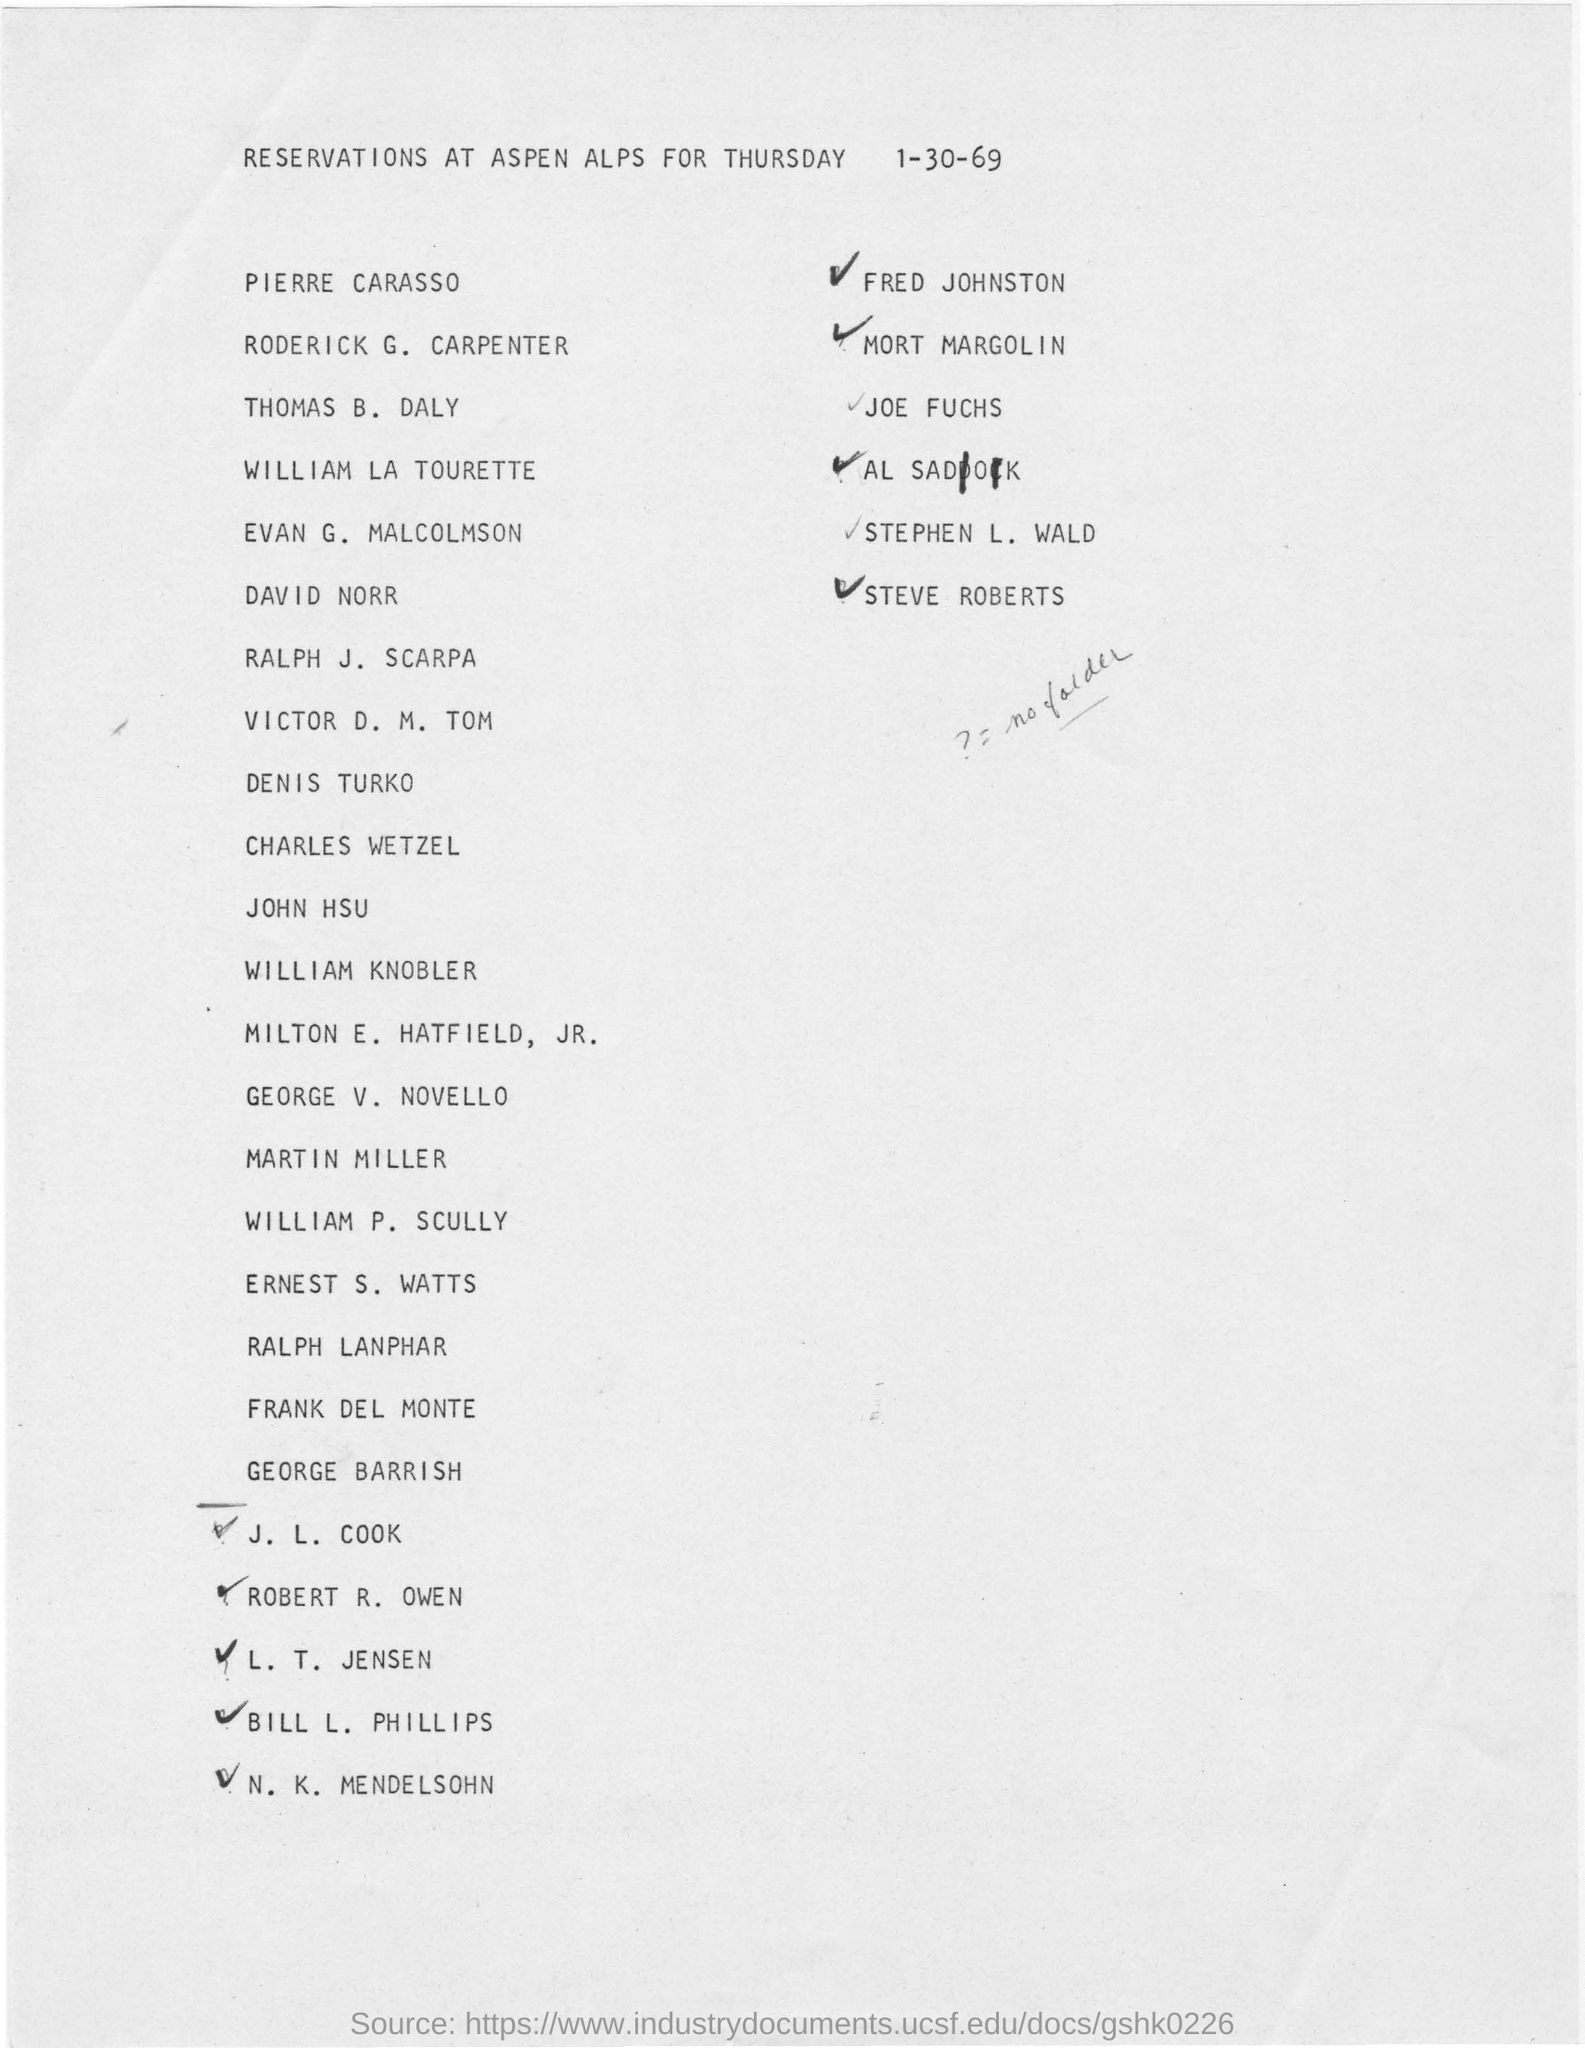Highlight a few significant elements in this photo. The reservations are made for Thursday. 